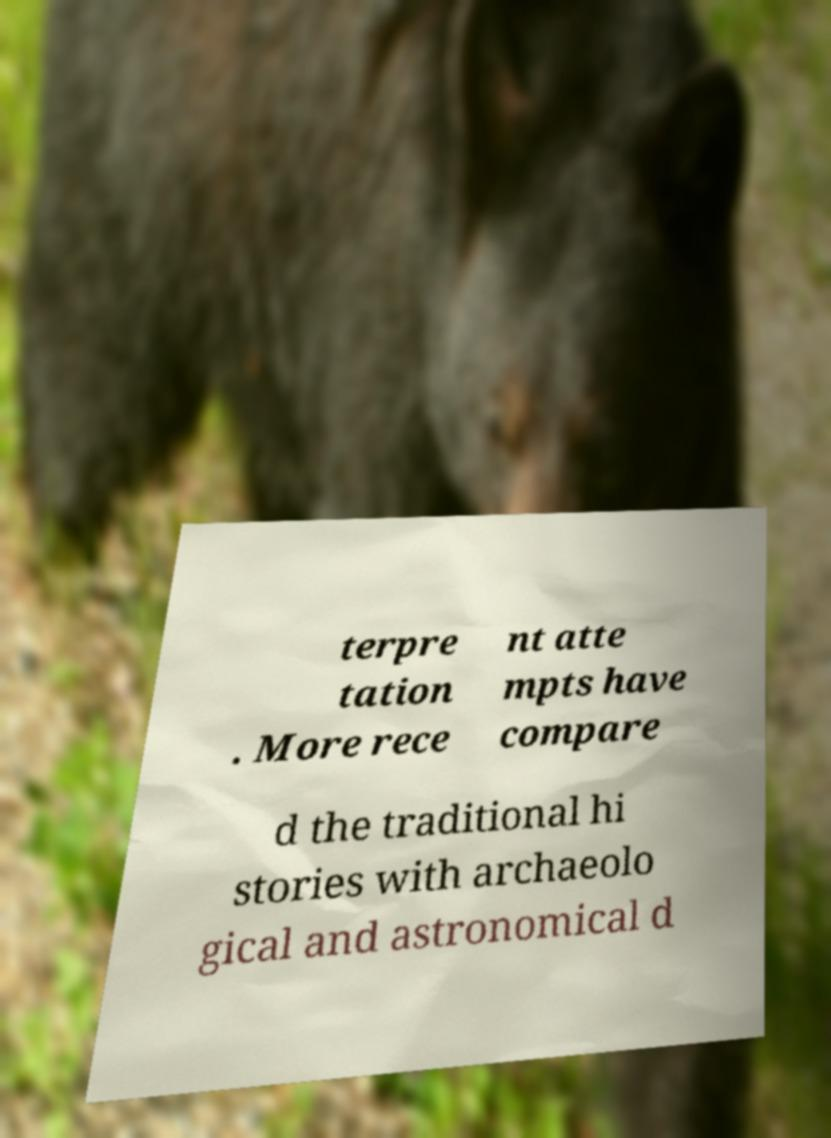Can you accurately transcribe the text from the provided image for me? terpre tation . More rece nt atte mpts have compare d the traditional hi stories with archaeolo gical and astronomical d 